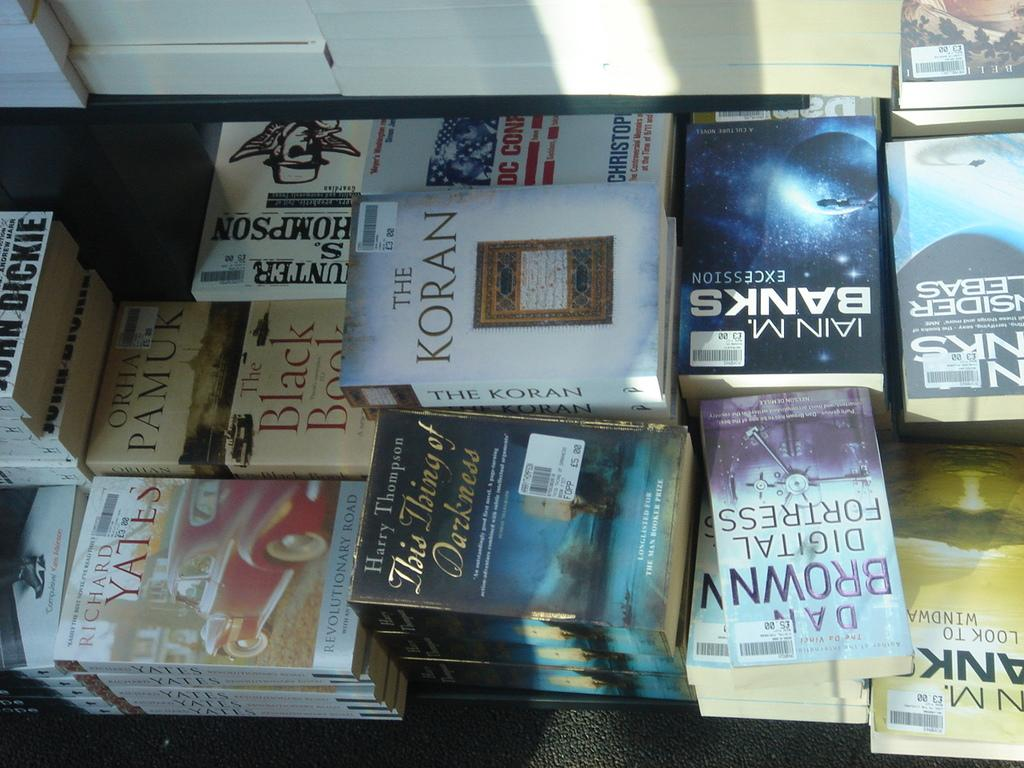<image>
Give a short and clear explanation of the subsequent image. A bundle of books, one of them being the koran 